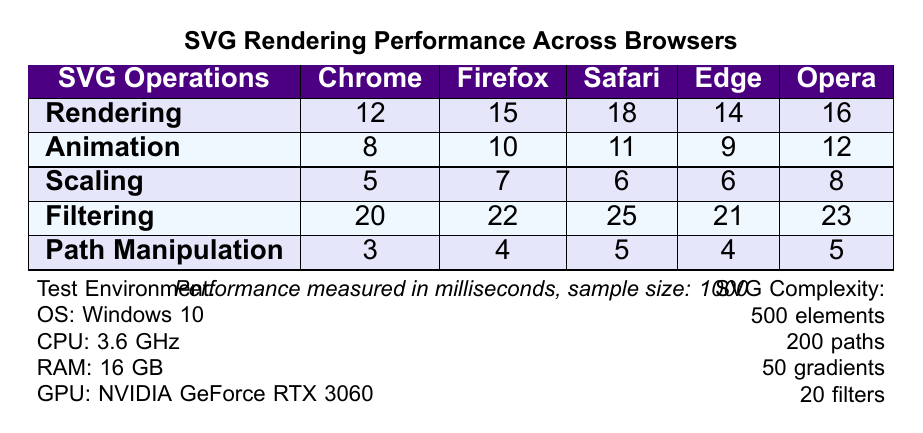What is the rendering time for Chrome? According to the table, the rendering time for Chrome is listed as 12 milliseconds.
Answer: 12 ms Which browser has the longest filtering time? The filtering times for each browser are as follows: 20 (Chrome), 22 (Firefox), 25 (Safari), 21 (Edge), and 23 (Opera). The longest time is 25 milliseconds for Safari.
Answer: Safari What is the average animation time across all browsers? The animation times are: 8 (Chrome), 10 (Firefox), 11 (Safari), 9 (Edge), and 12 (Opera). The sum of these times is 8 + 10 + 11 + 9 + 12 = 50 milliseconds. Dividing by 5 (the number of browsers), the average is 50/5 = 10 milliseconds.
Answer: 10 ms Is the path manipulation time the same for Opera and Edge? According to the table, the path manipulation time for Opera is 5 milliseconds and for Edge is 4 milliseconds. Hence, they are not the same.
Answer: No What is the difference in rendering time between Chrome and Firefox? The rendering time for Chrome is 12 milliseconds and for Firefox is 15 milliseconds. The difference is
Answer: 3 ms Which browser performs best in path manipulation? The path manipulation times are: 3 (Chrome), 4 (Firefox), 5 (Safari), 4 (Edge), and 5 (Opera). The best performance (lowest time) is with Chrome at 3 milliseconds.
Answer: Chrome What is the total rendering time for all browsers when rendering? The rendering times are as follows: 12 (Chrome), 15 (Firefox), 18 (Safari), 14 (Edge), and 16 (Opera). The total is 12 + 15 + 18 + 14 + 16 = 75 milliseconds.
Answer: 75 ms Does Chrome outperform Safari in animation time? The animation time for Chrome is 8 milliseconds, while for Safari it is 11 milliseconds. Since 8 is less than 11, Chrome does outperform Safari.
Answer: Yes What is the maximum time taken for any SVG operation across all browsers? The maximum times from each operation are: 20 (Rendering), 12 (Animation), 8 (Scaling), 25 (Filtering), and 5 (Path Manipulation). The overall maximum is 25 milliseconds for Filtering.
Answer: 25 ms What is the cumulative time for filtering across all browsers? The filtering times are: 20 (Chrome), 22 (Firefox), 25 (Safari), 21 (Edge), and 23 (Opera). The cumulative time is 20 + 22 + 25 + 21 + 23 = 111 milliseconds.
Answer: 111 ms 